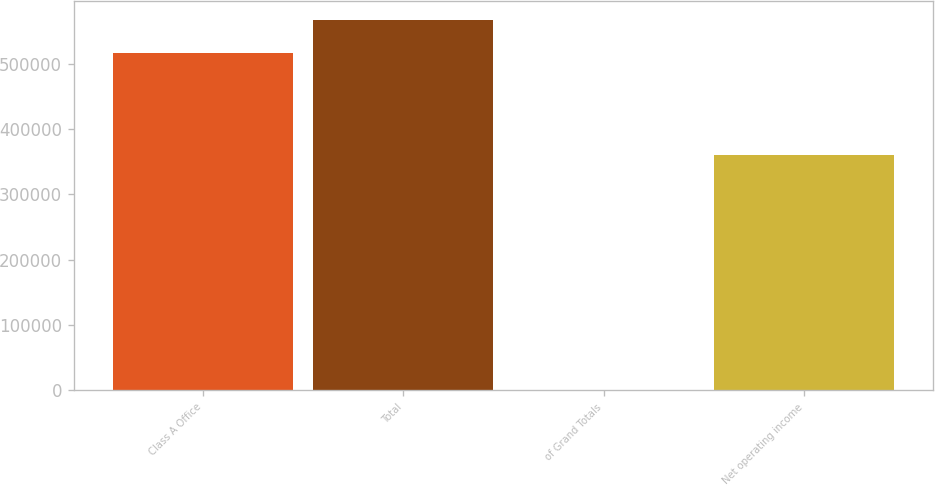<chart> <loc_0><loc_0><loc_500><loc_500><bar_chart><fcel>Class A Office<fcel>Total<fcel>of Grand Totals<fcel>Net operating income<nl><fcel>515401<fcel>566937<fcel>37.87<fcel>360444<nl></chart> 